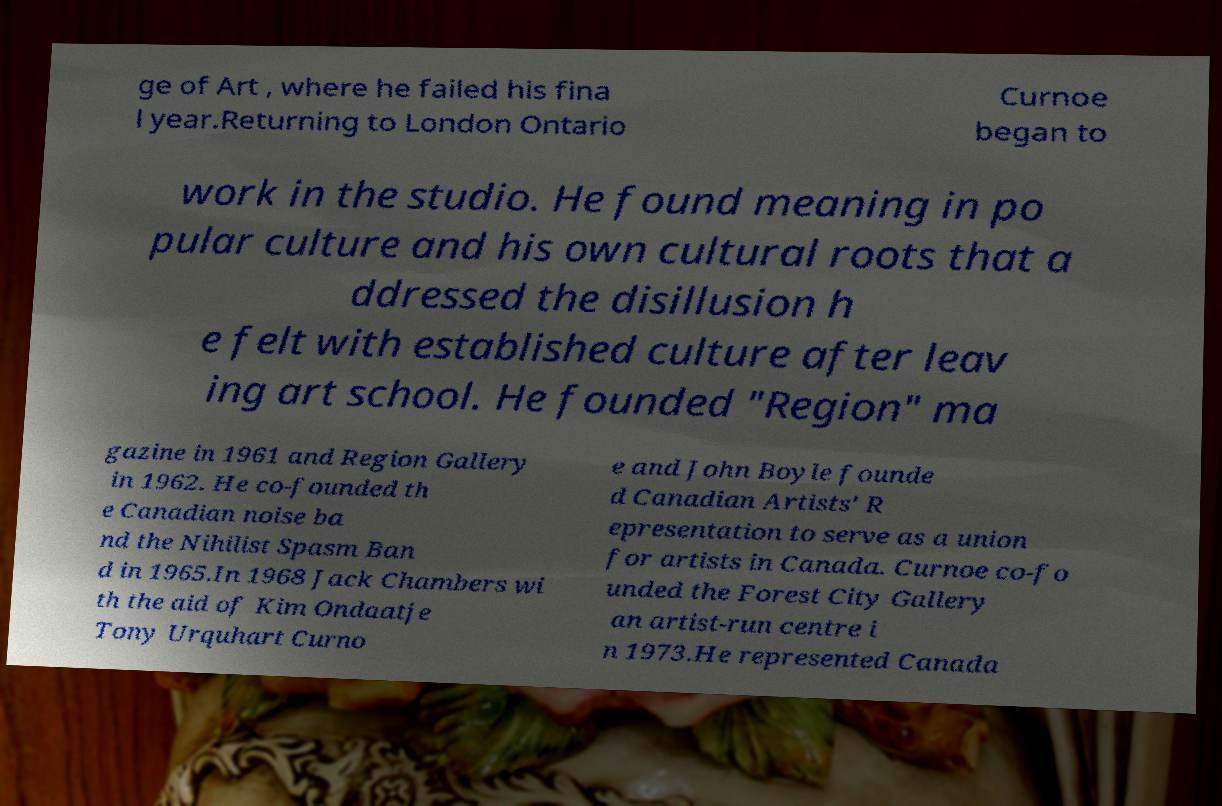Can you read and provide the text displayed in the image?This photo seems to have some interesting text. Can you extract and type it out for me? ge of Art , where he failed his fina l year.Returning to London Ontario Curnoe began to work in the studio. He found meaning in po pular culture and his own cultural roots that a ddressed the disillusion h e felt with established culture after leav ing art school. He founded "Region" ma gazine in 1961 and Region Gallery in 1962. He co-founded th e Canadian noise ba nd the Nihilist Spasm Ban d in 1965.In 1968 Jack Chambers wi th the aid of Kim Ondaatje Tony Urquhart Curno e and John Boyle founde d Canadian Artists' R epresentation to serve as a union for artists in Canada. Curnoe co-fo unded the Forest City Gallery an artist-run centre i n 1973.He represented Canada 